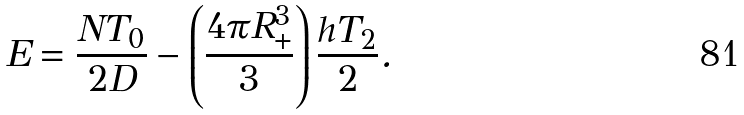<formula> <loc_0><loc_0><loc_500><loc_500>E = \frac { N T _ { 0 } } { 2 D } - \left ( \frac { 4 \pi R ^ { 3 } _ { + } } { 3 } \right ) \frac { h T _ { 2 } } { 2 } .</formula> 